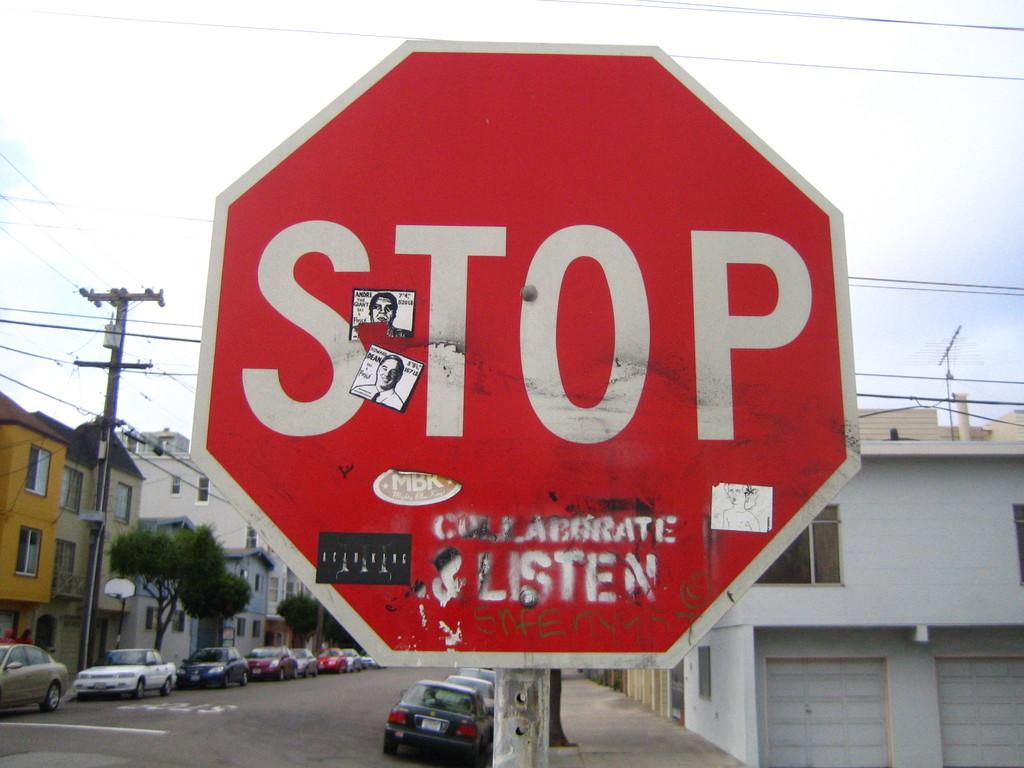<image>
Provide a brief description of the given image. A large sign says Stop and cars are in the background. 